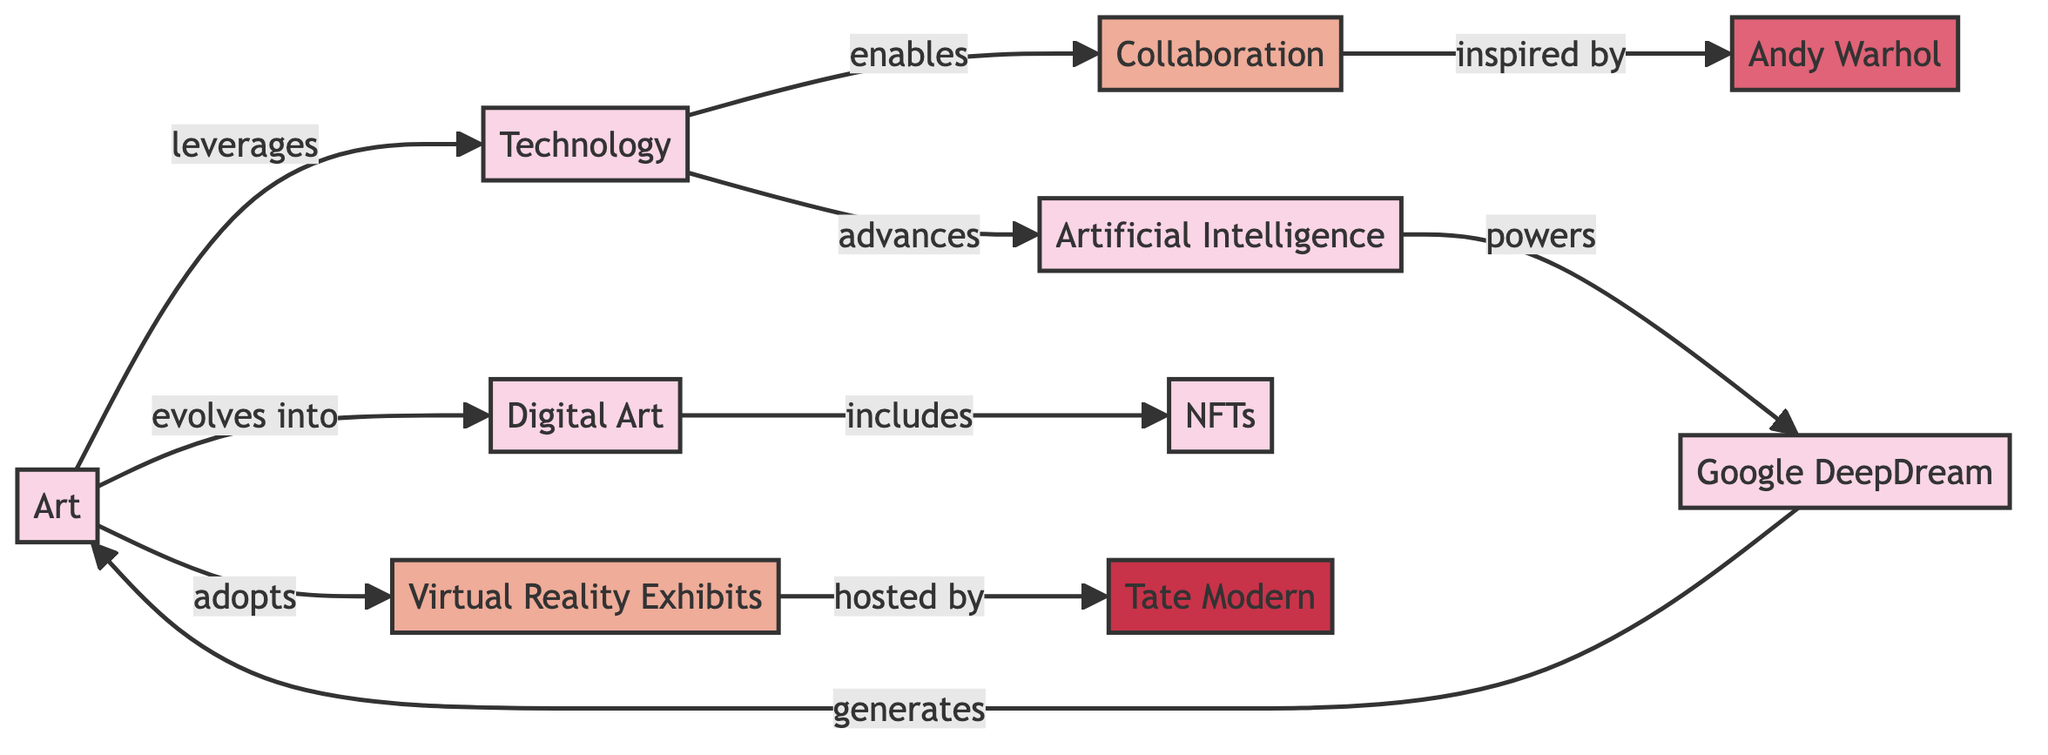What is the total number of nodes in the diagram? The diagram lists 10 entities, people, concepts, and organizations as nodes, contributing to the total.
Answer: 10 Which entity evolves into Digital Art? The arrow from Art pointing to Digital Art indicates that Art evolves into Digital Art.
Answer: Art What relationship does Technology have with Collaboration? The diagram shows a directed edge from Technology to Collaboration labeled as 'enables,' indicating this relationship.
Answer: enables How many entities are included in Digital Art? Digital Art includes one entity, which is NFTs, as shown by the directed edge leading from Digital Art to NFTs.
Answer: 1 What concept is inspired by Andy Warhol? The edge labeled 'inspired by' connects Collaboration to Andy Warhol, indicating that Collaboration is inspired by him.
Answer: Collaboration Which two nodes share a direct relationship with Artificial Intelligence? The directed edges from Technology to Artificial Intelligence and from Artificial Intelligence to Google DeepDream indicate these connections. The two nodes are Technology and Google DeepDream.
Answer: Technology, Google DeepDream What entity does Technology advance? The diagram shows that Technology advances Artificial Intelligence, indicated by the directed edge labeled 'advances.'
Answer: Artificial Intelligence Which organization hosts Virtual Reality Exhibits? The directed edge from Virtual Reality Exhibits to Tate Modern shows that Tate Modern hosts these exhibits.
Answer: Tate Modern What is the relationship labeled on the edge from Google DeepDream to Art? The directed edge from Google DeepDream to Art is labeled 'generates,' indicating the relationship between them.
Answer: generates 